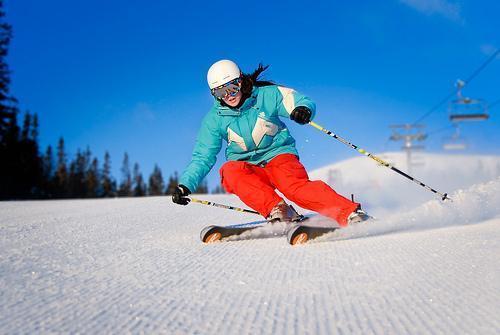How many people are there?
Give a very brief answer. 1. 